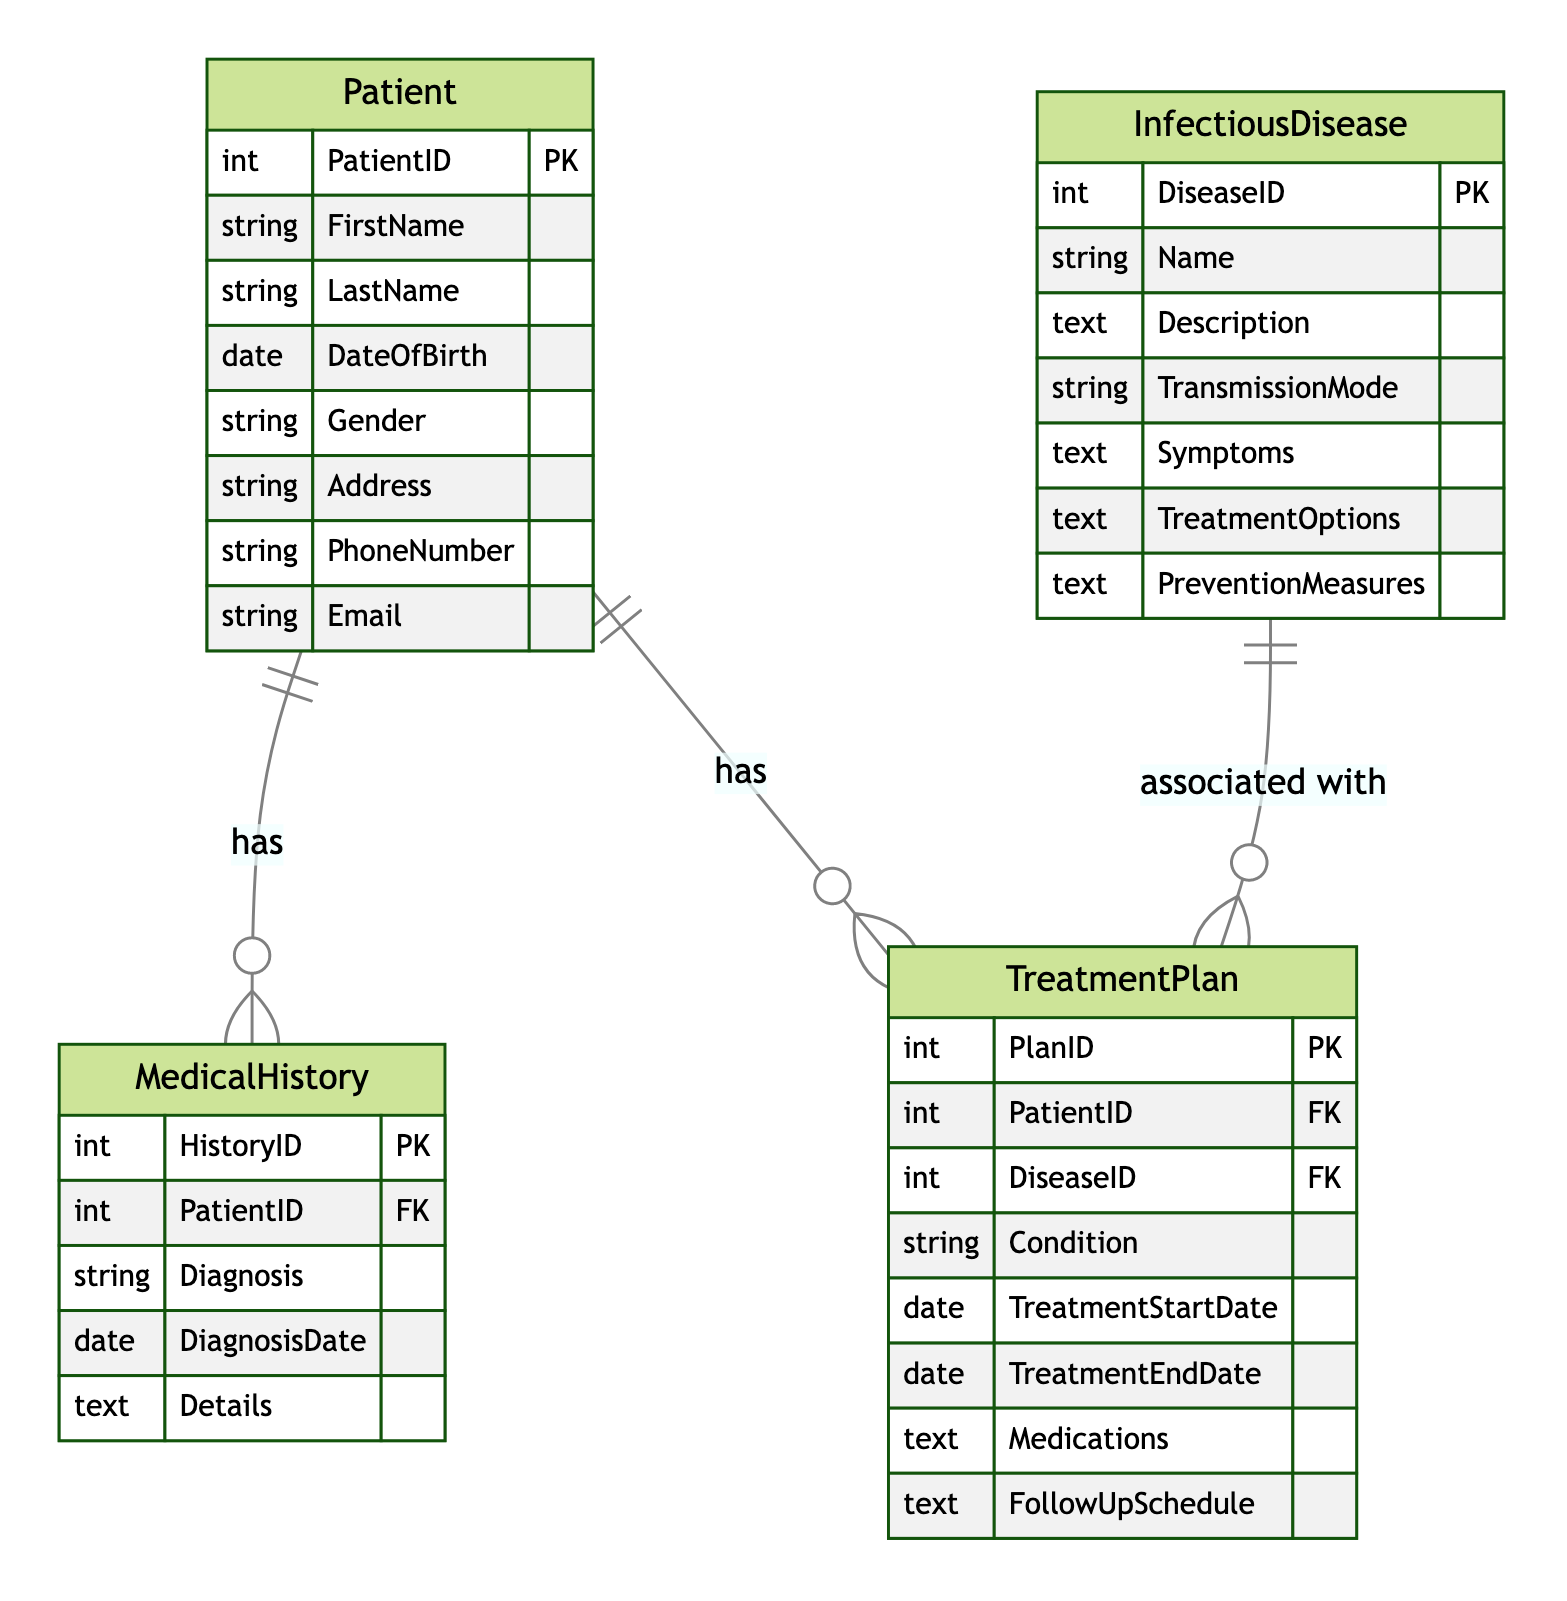What is the primary key of the Patient entity? The Patient entity has one primary key, which is PatientID. It is identified as a unique identifier for each patient in the system.
Answer: PatientID How many entities are there in the diagram? The diagram contains four entities: Patient, MedicalHistory, TreatmentPlan, and InfectiousDisease. This is a direct count of the entities listed in the diagram.
Answer: Four What is the relationship between Patient and MedicalHistory? The relationship between Patient and MedicalHistory is defined as "has", indicating that one patient can have multiple medical histories. This is a one-to-many relationship.
Answer: has What attribute links MedicalHistory to the Patient entity? The attribute that links MedicalHistory to Patient is PatientID, which serves as a foreign key in the MedicalHistory entity, referencing the Patient entity.
Answer: PatientID Which entity contains information about infectious diseases? The entity that contains information about infectious diseases is InfectiousDisease, which includes details such as name, description, and symptoms.
Answer: InfectiousDisease What type of relationship exists between TreatmentPlan and InfectiousDisease? The type of relationship between TreatmentPlan and InfectiousDisease is one-to-many, indicating that one infectious disease can be associated with multiple treatment plans.
Answer: One-to-many How many attributes does the TreatmentPlan entity have? The TreatmentPlan entity contains six attributes: PlanID, PatientID, DiseaseID, Condition, TreatmentStartDate, TreatmentEndDate, Medications, and FollowUpSchedule. This can be counted directly from the entity's attributes.
Answer: Six What is a foreign key in the MedicalHistory entity? The foreign key in the MedicalHistory entity is PatientID, which references the Patient entity, establishing the connection between patient records and their respective medical history.
Answer: PatientID What does the TreatmentPlan entity track besides dates? Besides dates, the TreatmentPlan entity tracks the condition, medications, and follow-up schedule related to the treatment for a patient. These attributes are key to managing the patient's treatment process.
Answer: Condition, medications, follow-up schedule 